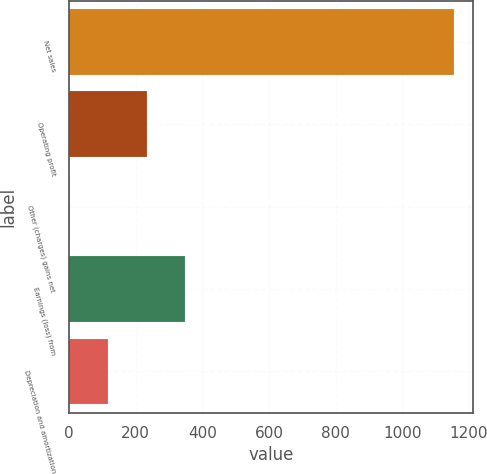<chart> <loc_0><loc_0><loc_500><loc_500><bar_chart><fcel>Net sales<fcel>Operating profit<fcel>Other (charges) gains net<fcel>Earnings (loss) from<fcel>Depreciation and amortization<nl><fcel>1155<fcel>232.6<fcel>2<fcel>347.9<fcel>117.3<nl></chart> 